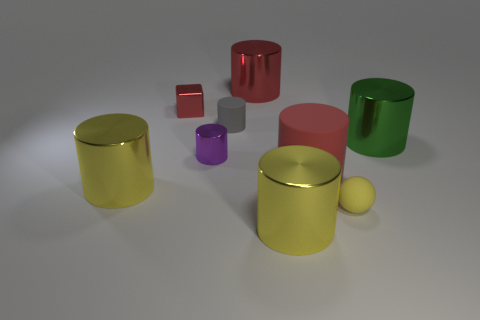Subtract all big metal cylinders. How many cylinders are left? 3 Subtract all gray cylinders. How many cylinders are left? 6 Subtract 1 blocks. How many blocks are left? 0 Subtract all blocks. How many objects are left? 8 Subtract all green balls. Subtract all yellow cubes. How many balls are left? 1 Subtract all blue spheres. How many green cylinders are left? 1 Subtract all yellow metal cylinders. Subtract all small red metal cubes. How many objects are left? 6 Add 8 small shiny cylinders. How many small shiny cylinders are left? 9 Add 4 small gray cylinders. How many small gray cylinders exist? 5 Subtract 2 red cylinders. How many objects are left? 7 